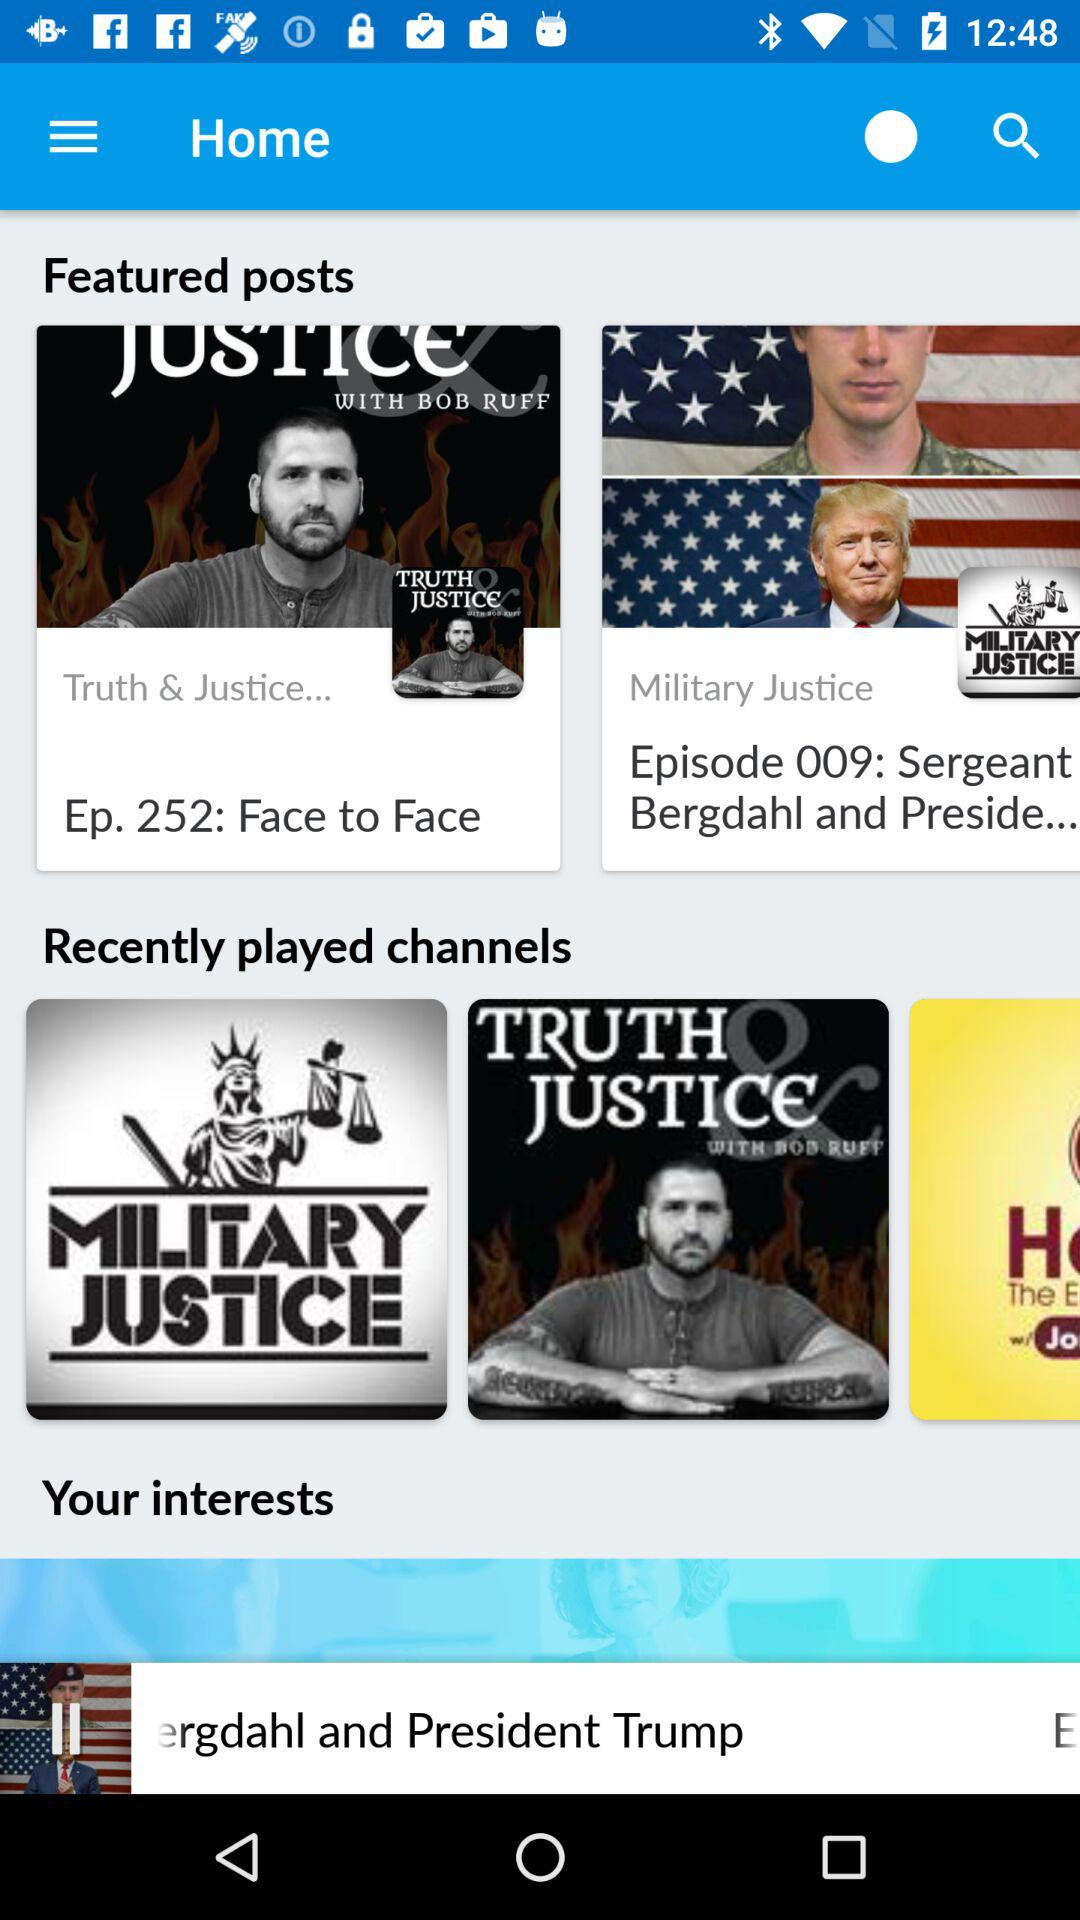What "Military Justice" episode are we on right now? You are on episode 9. 